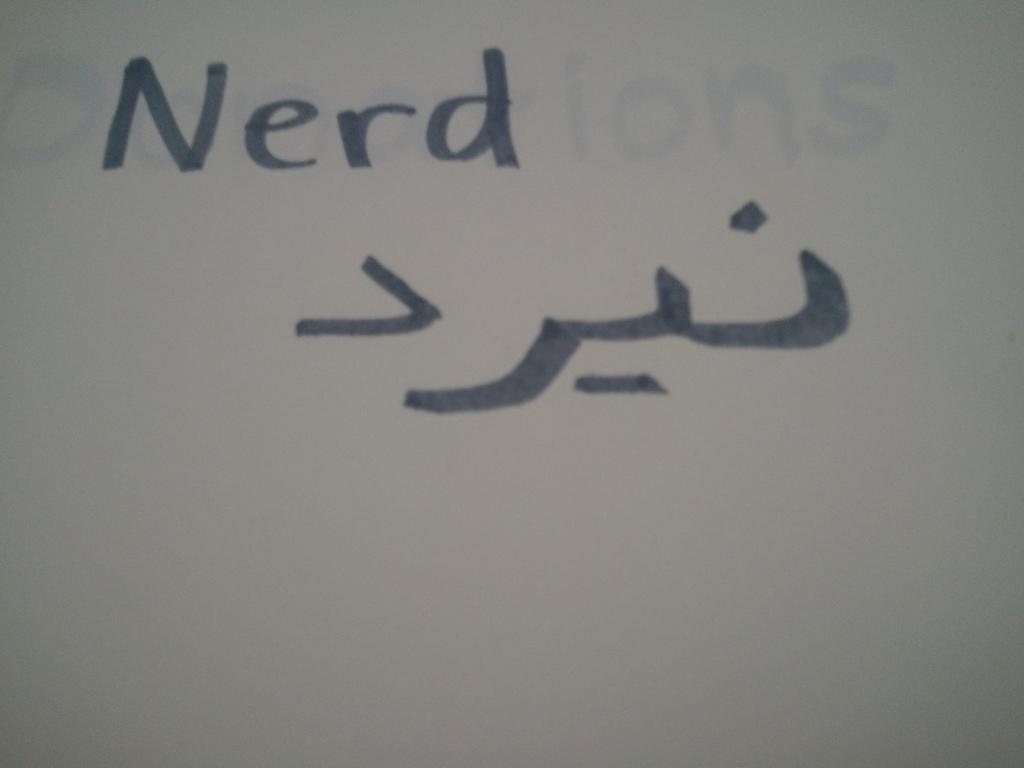<image>
Summarize the visual content of the image. Someone has written Nerd on a white board in black marker. 